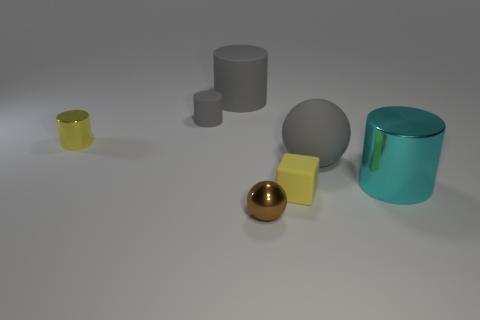There is a metallic cylinder that is behind the big cylinder on the right side of the tiny yellow matte thing; how many big cyan cylinders are on the right side of it?
Keep it short and to the point. 1. There is a tiny shiny sphere that is on the left side of the tiny yellow object that is in front of the large shiny object; what color is it?
Give a very brief answer. Brown. How many other objects are the same material as the brown sphere?
Provide a succinct answer. 2. There is a tiny brown thing that is to the left of the big cyan object; how many yellow cylinders are right of it?
Provide a succinct answer. 0. Are there any other things that are the same shape as the yellow matte thing?
Your answer should be compact. No. There is a big object to the left of the metal ball; does it have the same color as the small rubber object behind the large cyan shiny thing?
Offer a very short reply. Yes. Is the number of small cylinders less than the number of large shiny objects?
Your answer should be very brief. No. There is a big gray rubber object that is on the right side of the gray rubber cylinder that is behind the tiny gray matte cylinder; what is its shape?
Make the answer very short. Sphere. There is a big gray matte object in front of the tiny metallic thing behind the object that is in front of the small yellow block; what is its shape?
Offer a terse response. Sphere. How many things are either cylinders to the left of the large cyan metal thing or things behind the big gray matte sphere?
Offer a terse response. 3. 